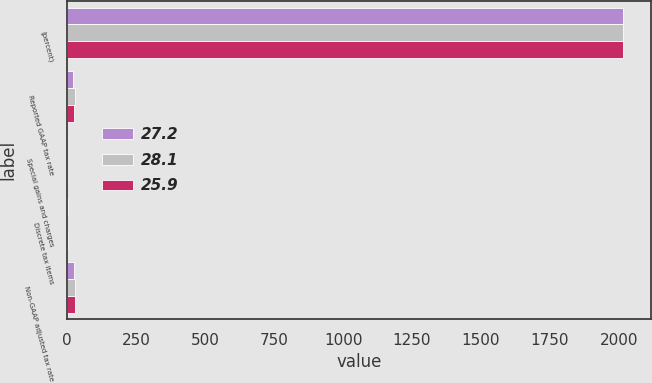Convert chart. <chart><loc_0><loc_0><loc_500><loc_500><stacked_bar_chart><ecel><fcel>(percent)<fcel>Reported GAAP tax rate<fcel>Special gains and charges<fcel>Discrete tax items<fcel>Non-GAAP adjusted tax rate<nl><fcel>27.2<fcel>2015<fcel>22.8<fcel>0.4<fcel>3.5<fcel>25.9<nl><fcel>28.1<fcel>2014<fcel>28<fcel>0.1<fcel>0.7<fcel>27.2<nl><fcel>25.9<fcel>2013<fcel>25<fcel>0.4<fcel>2.7<fcel>28.1<nl></chart> 